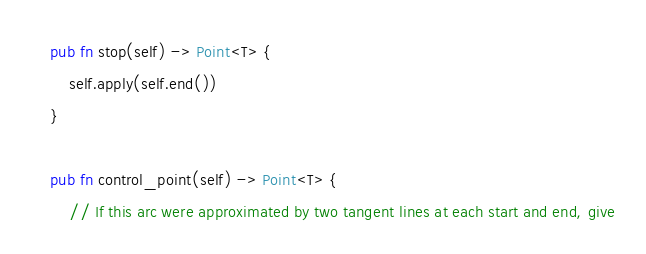<code> <loc_0><loc_0><loc_500><loc_500><_Rust_>
    pub fn stop(self) -> Point<T> {
        self.apply(self.end())
    }

    pub fn control_point(self) -> Point<T> {
        // If this arc were approximated by two tangent lines at each start and end, give</code> 